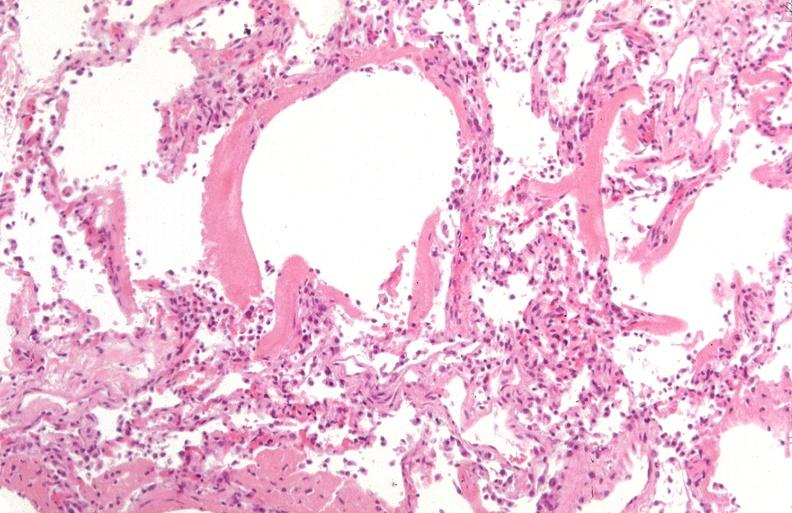does vasculitis foreign body show lung?
Answer the question using a single word or phrase. No 